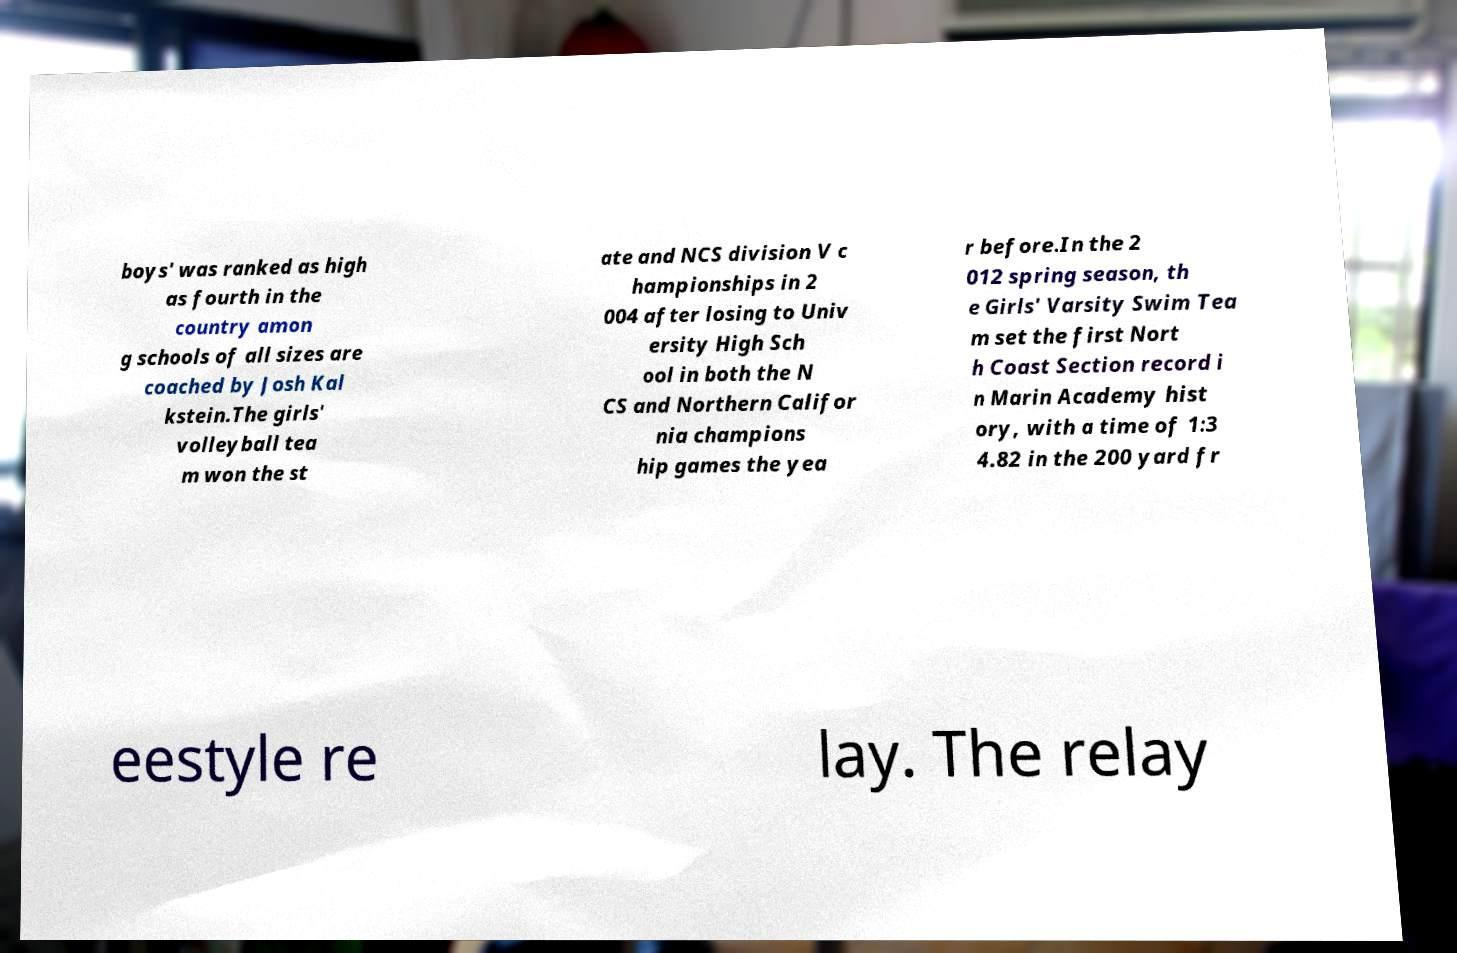There's text embedded in this image that I need extracted. Can you transcribe it verbatim? boys' was ranked as high as fourth in the country amon g schools of all sizes are coached by Josh Kal kstein.The girls' volleyball tea m won the st ate and NCS division V c hampionships in 2 004 after losing to Univ ersity High Sch ool in both the N CS and Northern Califor nia champions hip games the yea r before.In the 2 012 spring season, th e Girls' Varsity Swim Tea m set the first Nort h Coast Section record i n Marin Academy hist ory, with a time of 1:3 4.82 in the 200 yard fr eestyle re lay. The relay 